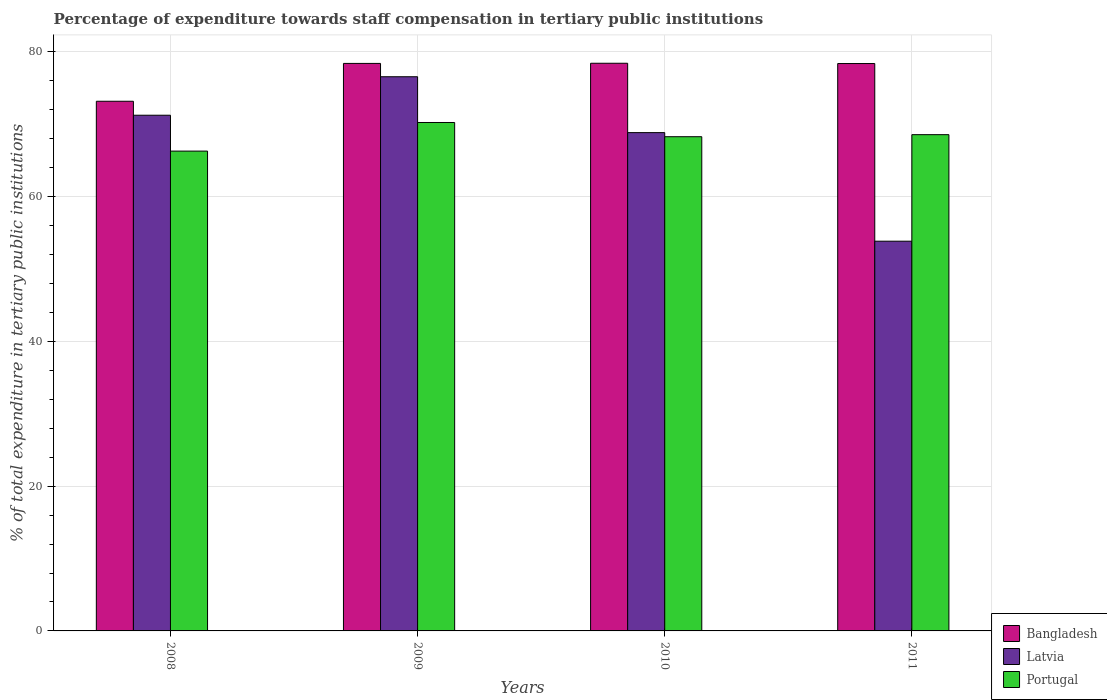How many different coloured bars are there?
Ensure brevity in your answer.  3. How many groups of bars are there?
Offer a very short reply. 4. Are the number of bars per tick equal to the number of legend labels?
Your response must be concise. Yes. Are the number of bars on each tick of the X-axis equal?
Provide a succinct answer. Yes. What is the label of the 4th group of bars from the left?
Offer a very short reply. 2011. In how many cases, is the number of bars for a given year not equal to the number of legend labels?
Provide a short and direct response. 0. What is the percentage of expenditure towards staff compensation in Portugal in 2009?
Offer a very short reply. 70.24. Across all years, what is the maximum percentage of expenditure towards staff compensation in Portugal?
Your answer should be compact. 70.24. Across all years, what is the minimum percentage of expenditure towards staff compensation in Portugal?
Make the answer very short. 66.28. In which year was the percentage of expenditure towards staff compensation in Portugal minimum?
Make the answer very short. 2008. What is the total percentage of expenditure towards staff compensation in Bangladesh in the graph?
Ensure brevity in your answer.  308.37. What is the difference between the percentage of expenditure towards staff compensation in Latvia in 2008 and that in 2011?
Your answer should be very brief. 17.4. What is the difference between the percentage of expenditure towards staff compensation in Bangladesh in 2008 and the percentage of expenditure towards staff compensation in Latvia in 2010?
Give a very brief answer. 4.33. What is the average percentage of expenditure towards staff compensation in Portugal per year?
Offer a terse response. 68.34. In the year 2009, what is the difference between the percentage of expenditure towards staff compensation in Bangladesh and percentage of expenditure towards staff compensation in Portugal?
Your answer should be compact. 8.16. In how many years, is the percentage of expenditure towards staff compensation in Portugal greater than 76 %?
Offer a very short reply. 0. What is the ratio of the percentage of expenditure towards staff compensation in Latvia in 2010 to that in 2011?
Offer a very short reply. 1.28. Is the percentage of expenditure towards staff compensation in Portugal in 2008 less than that in 2009?
Your answer should be compact. Yes. Is the difference between the percentage of expenditure towards staff compensation in Bangladesh in 2010 and 2011 greater than the difference between the percentage of expenditure towards staff compensation in Portugal in 2010 and 2011?
Your response must be concise. Yes. What is the difference between the highest and the second highest percentage of expenditure towards staff compensation in Latvia?
Your response must be concise. 5.32. What is the difference between the highest and the lowest percentage of expenditure towards staff compensation in Bangladesh?
Ensure brevity in your answer.  5.25. What does the 3rd bar from the left in 2011 represents?
Your answer should be very brief. Portugal. What does the 2nd bar from the right in 2010 represents?
Your response must be concise. Latvia. Is it the case that in every year, the sum of the percentage of expenditure towards staff compensation in Portugal and percentage of expenditure towards staff compensation in Latvia is greater than the percentage of expenditure towards staff compensation in Bangladesh?
Ensure brevity in your answer.  Yes. How many bars are there?
Your answer should be very brief. 12. Are the values on the major ticks of Y-axis written in scientific E-notation?
Keep it short and to the point. No. Does the graph contain grids?
Give a very brief answer. Yes. What is the title of the graph?
Your response must be concise. Percentage of expenditure towards staff compensation in tertiary public institutions. What is the label or title of the Y-axis?
Your answer should be compact. % of total expenditure in tertiary public institutions. What is the % of total expenditure in tertiary public institutions in Bangladesh in 2008?
Your answer should be very brief. 73.17. What is the % of total expenditure in tertiary public institutions of Latvia in 2008?
Offer a terse response. 71.24. What is the % of total expenditure in tertiary public institutions of Portugal in 2008?
Make the answer very short. 66.28. What is the % of total expenditure in tertiary public institutions in Bangladesh in 2009?
Keep it short and to the point. 78.4. What is the % of total expenditure in tertiary public institutions in Latvia in 2009?
Offer a very short reply. 76.56. What is the % of total expenditure in tertiary public institutions in Portugal in 2009?
Offer a very short reply. 70.24. What is the % of total expenditure in tertiary public institutions of Bangladesh in 2010?
Offer a terse response. 78.42. What is the % of total expenditure in tertiary public institutions in Latvia in 2010?
Make the answer very short. 68.84. What is the % of total expenditure in tertiary public institutions in Portugal in 2010?
Offer a very short reply. 68.27. What is the % of total expenditure in tertiary public institutions of Bangladesh in 2011?
Provide a succinct answer. 78.38. What is the % of total expenditure in tertiary public institutions of Latvia in 2011?
Give a very brief answer. 53.84. What is the % of total expenditure in tertiary public institutions in Portugal in 2011?
Your answer should be compact. 68.56. Across all years, what is the maximum % of total expenditure in tertiary public institutions in Bangladesh?
Your answer should be compact. 78.42. Across all years, what is the maximum % of total expenditure in tertiary public institutions in Latvia?
Your response must be concise. 76.56. Across all years, what is the maximum % of total expenditure in tertiary public institutions in Portugal?
Your response must be concise. 70.24. Across all years, what is the minimum % of total expenditure in tertiary public institutions in Bangladesh?
Provide a succinct answer. 73.17. Across all years, what is the minimum % of total expenditure in tertiary public institutions in Latvia?
Offer a terse response. 53.84. Across all years, what is the minimum % of total expenditure in tertiary public institutions in Portugal?
Make the answer very short. 66.28. What is the total % of total expenditure in tertiary public institutions in Bangladesh in the graph?
Offer a very short reply. 308.37. What is the total % of total expenditure in tertiary public institutions of Latvia in the graph?
Provide a succinct answer. 270.47. What is the total % of total expenditure in tertiary public institutions of Portugal in the graph?
Ensure brevity in your answer.  273.35. What is the difference between the % of total expenditure in tertiary public institutions in Bangladesh in 2008 and that in 2009?
Keep it short and to the point. -5.23. What is the difference between the % of total expenditure in tertiary public institutions of Latvia in 2008 and that in 2009?
Provide a short and direct response. -5.32. What is the difference between the % of total expenditure in tertiary public institutions in Portugal in 2008 and that in 2009?
Give a very brief answer. -3.95. What is the difference between the % of total expenditure in tertiary public institutions in Bangladesh in 2008 and that in 2010?
Offer a terse response. -5.25. What is the difference between the % of total expenditure in tertiary public institutions in Latvia in 2008 and that in 2010?
Offer a terse response. 2.4. What is the difference between the % of total expenditure in tertiary public institutions of Portugal in 2008 and that in 2010?
Offer a very short reply. -1.99. What is the difference between the % of total expenditure in tertiary public institutions of Bangladesh in 2008 and that in 2011?
Give a very brief answer. -5.21. What is the difference between the % of total expenditure in tertiary public institutions in Latvia in 2008 and that in 2011?
Keep it short and to the point. 17.4. What is the difference between the % of total expenditure in tertiary public institutions in Portugal in 2008 and that in 2011?
Make the answer very short. -2.27. What is the difference between the % of total expenditure in tertiary public institutions in Bangladesh in 2009 and that in 2010?
Offer a very short reply. -0.02. What is the difference between the % of total expenditure in tertiary public institutions in Latvia in 2009 and that in 2010?
Provide a short and direct response. 7.72. What is the difference between the % of total expenditure in tertiary public institutions of Portugal in 2009 and that in 2010?
Give a very brief answer. 1.96. What is the difference between the % of total expenditure in tertiary public institutions in Bangladesh in 2009 and that in 2011?
Ensure brevity in your answer.  0.02. What is the difference between the % of total expenditure in tertiary public institutions in Latvia in 2009 and that in 2011?
Ensure brevity in your answer.  22.72. What is the difference between the % of total expenditure in tertiary public institutions in Portugal in 2009 and that in 2011?
Your response must be concise. 1.68. What is the difference between the % of total expenditure in tertiary public institutions of Bangladesh in 2010 and that in 2011?
Provide a short and direct response. 0.04. What is the difference between the % of total expenditure in tertiary public institutions in Latvia in 2010 and that in 2011?
Provide a succinct answer. 15. What is the difference between the % of total expenditure in tertiary public institutions in Portugal in 2010 and that in 2011?
Your answer should be very brief. -0.28. What is the difference between the % of total expenditure in tertiary public institutions of Bangladesh in 2008 and the % of total expenditure in tertiary public institutions of Latvia in 2009?
Ensure brevity in your answer.  -3.39. What is the difference between the % of total expenditure in tertiary public institutions in Bangladesh in 2008 and the % of total expenditure in tertiary public institutions in Portugal in 2009?
Your response must be concise. 2.93. What is the difference between the % of total expenditure in tertiary public institutions of Bangladesh in 2008 and the % of total expenditure in tertiary public institutions of Latvia in 2010?
Your answer should be very brief. 4.33. What is the difference between the % of total expenditure in tertiary public institutions of Bangladesh in 2008 and the % of total expenditure in tertiary public institutions of Portugal in 2010?
Keep it short and to the point. 4.9. What is the difference between the % of total expenditure in tertiary public institutions in Latvia in 2008 and the % of total expenditure in tertiary public institutions in Portugal in 2010?
Your answer should be compact. 2.97. What is the difference between the % of total expenditure in tertiary public institutions in Bangladesh in 2008 and the % of total expenditure in tertiary public institutions in Latvia in 2011?
Keep it short and to the point. 19.33. What is the difference between the % of total expenditure in tertiary public institutions in Bangladesh in 2008 and the % of total expenditure in tertiary public institutions in Portugal in 2011?
Ensure brevity in your answer.  4.61. What is the difference between the % of total expenditure in tertiary public institutions in Latvia in 2008 and the % of total expenditure in tertiary public institutions in Portugal in 2011?
Your response must be concise. 2.68. What is the difference between the % of total expenditure in tertiary public institutions in Bangladesh in 2009 and the % of total expenditure in tertiary public institutions in Latvia in 2010?
Offer a very short reply. 9.56. What is the difference between the % of total expenditure in tertiary public institutions in Bangladesh in 2009 and the % of total expenditure in tertiary public institutions in Portugal in 2010?
Your answer should be compact. 10.13. What is the difference between the % of total expenditure in tertiary public institutions of Latvia in 2009 and the % of total expenditure in tertiary public institutions of Portugal in 2010?
Provide a short and direct response. 8.28. What is the difference between the % of total expenditure in tertiary public institutions of Bangladesh in 2009 and the % of total expenditure in tertiary public institutions of Latvia in 2011?
Keep it short and to the point. 24.56. What is the difference between the % of total expenditure in tertiary public institutions in Bangladesh in 2009 and the % of total expenditure in tertiary public institutions in Portugal in 2011?
Your response must be concise. 9.84. What is the difference between the % of total expenditure in tertiary public institutions in Latvia in 2009 and the % of total expenditure in tertiary public institutions in Portugal in 2011?
Give a very brief answer. 8. What is the difference between the % of total expenditure in tertiary public institutions of Bangladesh in 2010 and the % of total expenditure in tertiary public institutions of Latvia in 2011?
Give a very brief answer. 24.58. What is the difference between the % of total expenditure in tertiary public institutions in Bangladesh in 2010 and the % of total expenditure in tertiary public institutions in Portugal in 2011?
Keep it short and to the point. 9.86. What is the difference between the % of total expenditure in tertiary public institutions of Latvia in 2010 and the % of total expenditure in tertiary public institutions of Portugal in 2011?
Provide a short and direct response. 0.28. What is the average % of total expenditure in tertiary public institutions in Bangladesh per year?
Offer a terse response. 77.09. What is the average % of total expenditure in tertiary public institutions of Latvia per year?
Ensure brevity in your answer.  67.62. What is the average % of total expenditure in tertiary public institutions of Portugal per year?
Keep it short and to the point. 68.34. In the year 2008, what is the difference between the % of total expenditure in tertiary public institutions of Bangladesh and % of total expenditure in tertiary public institutions of Latvia?
Your answer should be very brief. 1.93. In the year 2008, what is the difference between the % of total expenditure in tertiary public institutions of Bangladesh and % of total expenditure in tertiary public institutions of Portugal?
Your response must be concise. 6.89. In the year 2008, what is the difference between the % of total expenditure in tertiary public institutions of Latvia and % of total expenditure in tertiary public institutions of Portugal?
Offer a terse response. 4.96. In the year 2009, what is the difference between the % of total expenditure in tertiary public institutions in Bangladesh and % of total expenditure in tertiary public institutions in Latvia?
Ensure brevity in your answer.  1.84. In the year 2009, what is the difference between the % of total expenditure in tertiary public institutions in Bangladesh and % of total expenditure in tertiary public institutions in Portugal?
Make the answer very short. 8.16. In the year 2009, what is the difference between the % of total expenditure in tertiary public institutions of Latvia and % of total expenditure in tertiary public institutions of Portugal?
Keep it short and to the point. 6.32. In the year 2010, what is the difference between the % of total expenditure in tertiary public institutions of Bangladesh and % of total expenditure in tertiary public institutions of Latvia?
Keep it short and to the point. 9.58. In the year 2010, what is the difference between the % of total expenditure in tertiary public institutions of Bangladesh and % of total expenditure in tertiary public institutions of Portugal?
Offer a very short reply. 10.15. In the year 2010, what is the difference between the % of total expenditure in tertiary public institutions of Latvia and % of total expenditure in tertiary public institutions of Portugal?
Your answer should be very brief. 0.56. In the year 2011, what is the difference between the % of total expenditure in tertiary public institutions in Bangladesh and % of total expenditure in tertiary public institutions in Latvia?
Offer a very short reply. 24.54. In the year 2011, what is the difference between the % of total expenditure in tertiary public institutions in Bangladesh and % of total expenditure in tertiary public institutions in Portugal?
Your response must be concise. 9.82. In the year 2011, what is the difference between the % of total expenditure in tertiary public institutions in Latvia and % of total expenditure in tertiary public institutions in Portugal?
Your answer should be very brief. -14.72. What is the ratio of the % of total expenditure in tertiary public institutions of Latvia in 2008 to that in 2009?
Offer a very short reply. 0.93. What is the ratio of the % of total expenditure in tertiary public institutions in Portugal in 2008 to that in 2009?
Provide a succinct answer. 0.94. What is the ratio of the % of total expenditure in tertiary public institutions in Bangladesh in 2008 to that in 2010?
Your answer should be very brief. 0.93. What is the ratio of the % of total expenditure in tertiary public institutions in Latvia in 2008 to that in 2010?
Offer a very short reply. 1.03. What is the ratio of the % of total expenditure in tertiary public institutions of Portugal in 2008 to that in 2010?
Your response must be concise. 0.97. What is the ratio of the % of total expenditure in tertiary public institutions in Bangladesh in 2008 to that in 2011?
Your response must be concise. 0.93. What is the ratio of the % of total expenditure in tertiary public institutions of Latvia in 2008 to that in 2011?
Your answer should be very brief. 1.32. What is the ratio of the % of total expenditure in tertiary public institutions of Portugal in 2008 to that in 2011?
Your response must be concise. 0.97. What is the ratio of the % of total expenditure in tertiary public institutions in Latvia in 2009 to that in 2010?
Offer a terse response. 1.11. What is the ratio of the % of total expenditure in tertiary public institutions of Portugal in 2009 to that in 2010?
Give a very brief answer. 1.03. What is the ratio of the % of total expenditure in tertiary public institutions of Latvia in 2009 to that in 2011?
Your answer should be very brief. 1.42. What is the ratio of the % of total expenditure in tertiary public institutions of Portugal in 2009 to that in 2011?
Your answer should be compact. 1.02. What is the ratio of the % of total expenditure in tertiary public institutions in Bangladesh in 2010 to that in 2011?
Provide a succinct answer. 1. What is the ratio of the % of total expenditure in tertiary public institutions in Latvia in 2010 to that in 2011?
Offer a terse response. 1.28. What is the ratio of the % of total expenditure in tertiary public institutions of Portugal in 2010 to that in 2011?
Make the answer very short. 1. What is the difference between the highest and the second highest % of total expenditure in tertiary public institutions in Bangladesh?
Keep it short and to the point. 0.02. What is the difference between the highest and the second highest % of total expenditure in tertiary public institutions in Latvia?
Your answer should be very brief. 5.32. What is the difference between the highest and the second highest % of total expenditure in tertiary public institutions of Portugal?
Give a very brief answer. 1.68. What is the difference between the highest and the lowest % of total expenditure in tertiary public institutions of Bangladesh?
Ensure brevity in your answer.  5.25. What is the difference between the highest and the lowest % of total expenditure in tertiary public institutions of Latvia?
Offer a very short reply. 22.72. What is the difference between the highest and the lowest % of total expenditure in tertiary public institutions in Portugal?
Provide a short and direct response. 3.95. 